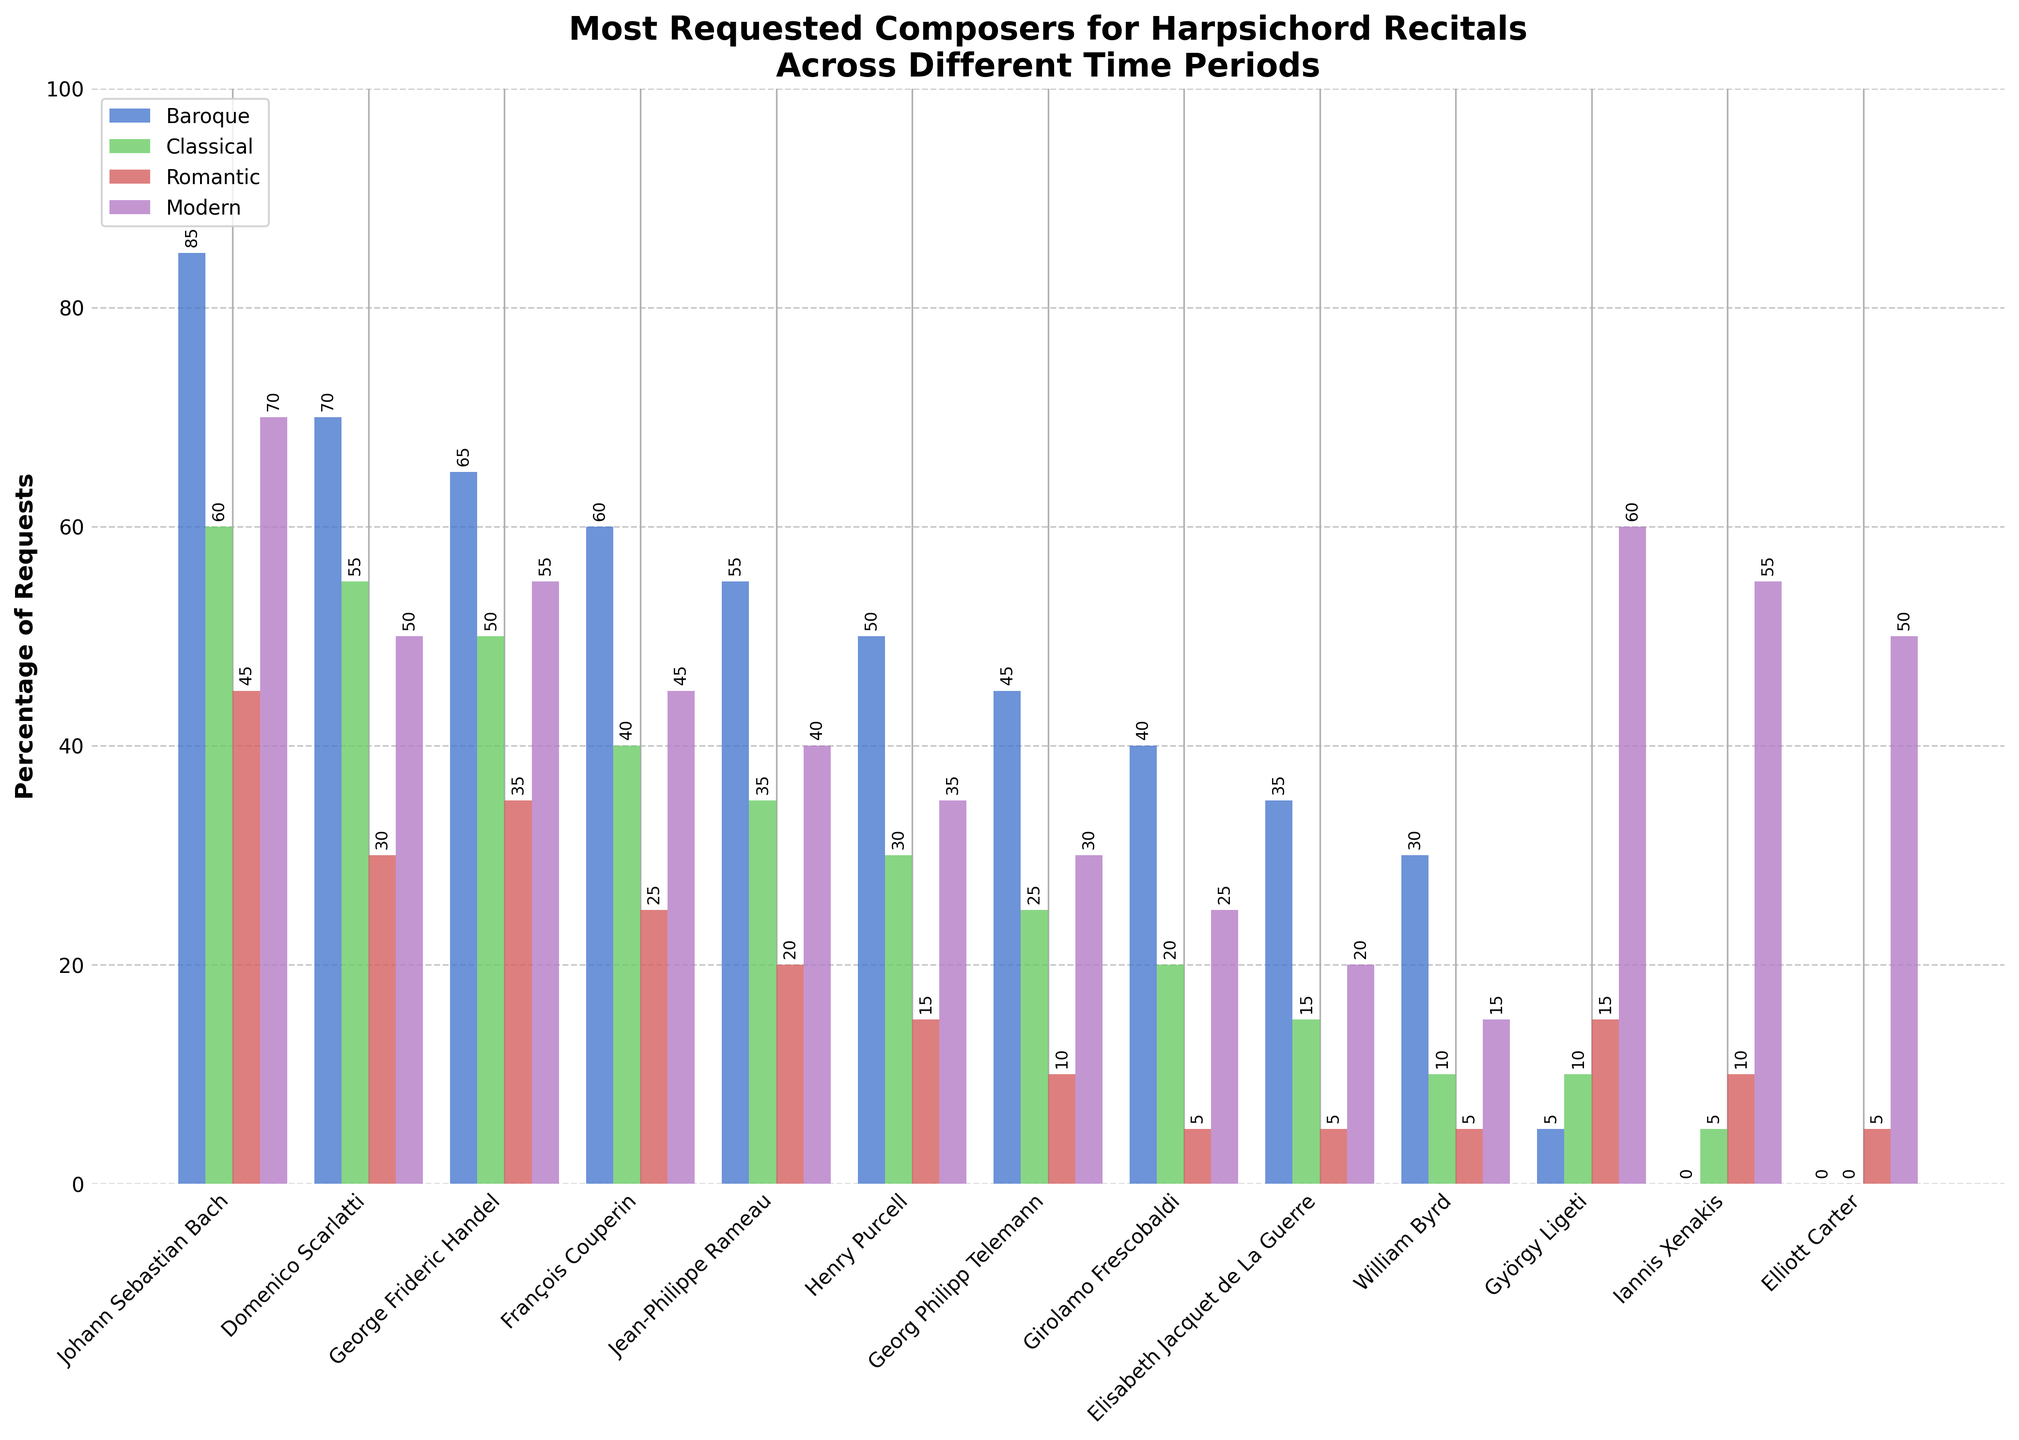Which composer has the highest percentage of requests in the Modern period? Look at the bar heights in the Modern period category and compare. The highest bar belongs to Johann Sebastian Bach.
Answer: Johann Sebastian Bach Which composer has the least percentage of requests in the Baroque period? Compare the bar heights in the Baroque period category. The smallest bar belongs to Elliott Carter.
Answer: Elliott Carter What is the total percentage of requests for Domenico Scarlatti across all periods? Add the percentages for each period for Domenico Scarlatti: 70 (Baroque) + 55 (Classical) + 30 (Romantic) + 50 (Modern). The total is 205.
Answer: 205 Which period has the largest cumulative percentage for Johann Sebastian Bach and Domenico Scarlatti combined? Sum the requests of both composers for each period and compare: 
- Baroque: (85 + 70) = 155
- Classical: (60 + 55) = 115
- Romantic: (45 + 30) = 75
- Modern: (70 + 50) = 120. 
Baroque has the largest sum.
Answer: Baroque How many composers have a higher percentage of requests in the Baroque period than in the Modern period? Compare the bar lengths of each composer in the Baroque and Modern periods. The composers are Johann Sebastian Bach, Domenico Scarlatti, George Frideric Handel, François Couperin, Jean-Philippe Rameau, Henry Purcell, Georg Philipp Telemann, Girolamo Frescobaldi, Elisabeth Jacquet de La Guerre, and William Byrd—they all have higher percentages in Baroque than Modern.
Answer: 10 What is the difference in requests percentage between Johann Sebastian Bach and Elliott Carter in the Classical period? Subtract the requests of Elliott Carter from Johann Sebastian Bach in the Classical period: 60 (Bach) - 0 (Carter) = 60.
Answer: 60 Among the listed composers, who has the highest number of requests in the Romantic period alone? Examine the heights of the bars in the Romantic period. Johann Sebastian Bach has the highest bar in the Romantic period.
Answer: Johann Sebastian Bach What is the average percentage of requests for George Frideric Handel across the four periods? Calculate the sum of requests for Handel in all periods and divide by 4. (65 + 50 + 35 + 55) / 4 = 205 / 4 = 51.25.
Answer: 51.25 Which composers have their highest request percentage in the Romantic period? Compare the heights of the bars for each composer in the Romantic period. The highest request percentages for György Ligeti, Iannis Xenakis, and Elliott Carter occur in the Romantic period.
Answer: György Ligeti, Iannis Xenakis, Elliott Carter 